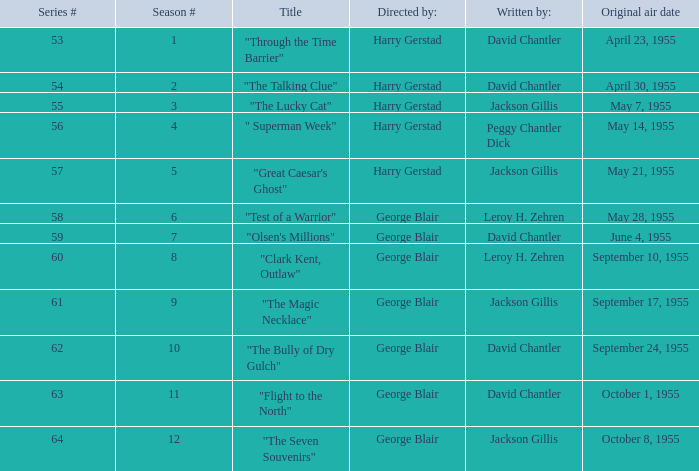What is the lowest number of series? 53.0. 